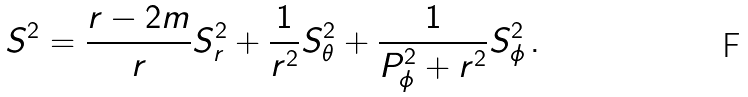Convert formula to latex. <formula><loc_0><loc_0><loc_500><loc_500>S ^ { 2 } = \frac { r - 2 m } { r } S _ { r } ^ { 2 } + \frac { 1 } { r ^ { 2 } } S _ { \theta } ^ { 2 } + \frac { 1 } { P _ { \phi } ^ { 2 } + r ^ { 2 } } S _ { \phi } ^ { 2 } \, .</formula> 